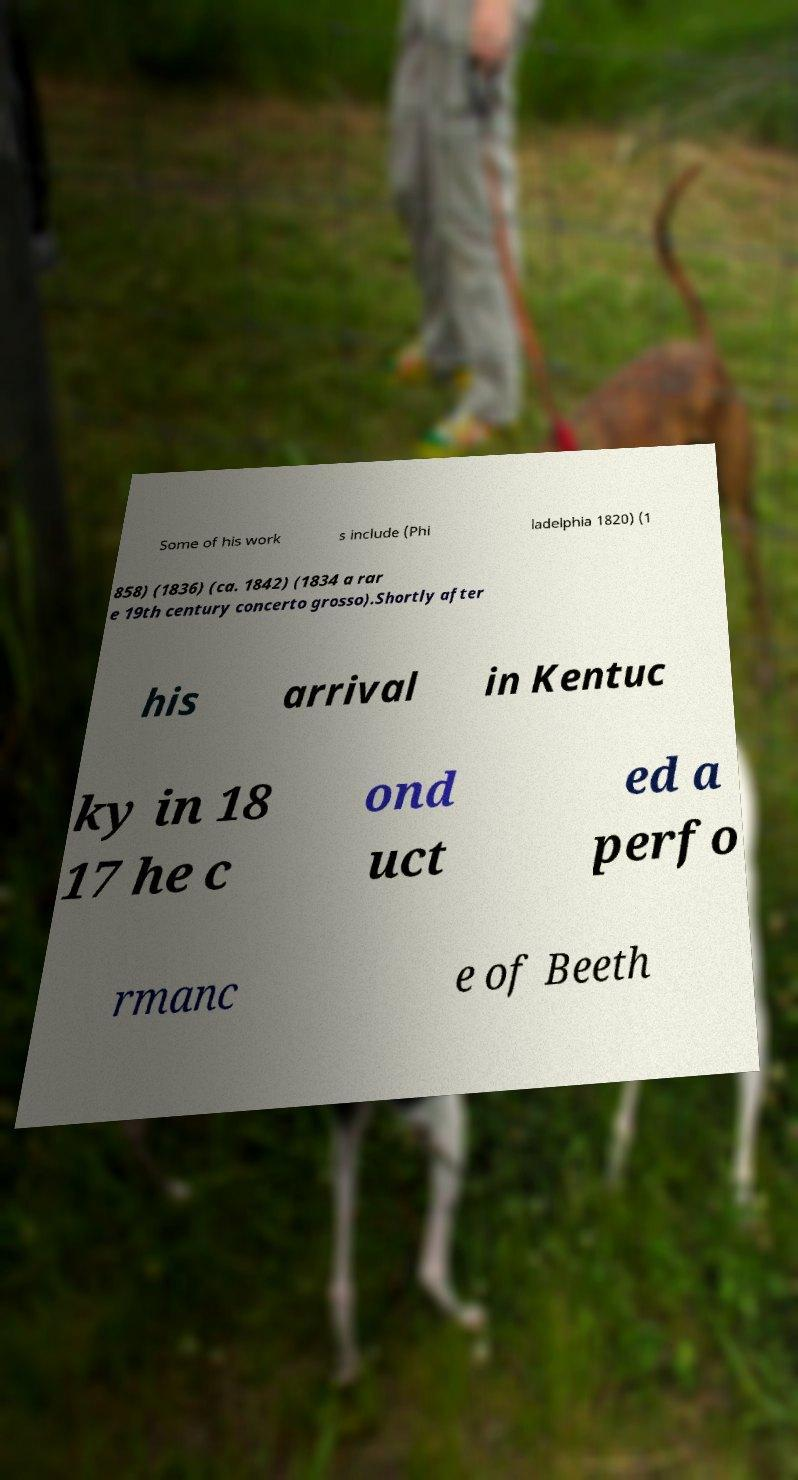Could you extract and type out the text from this image? Some of his work s include (Phi ladelphia 1820) (1 858) (1836) (ca. 1842) (1834 a rar e 19th century concerto grosso).Shortly after his arrival in Kentuc ky in 18 17 he c ond uct ed a perfo rmanc e of Beeth 